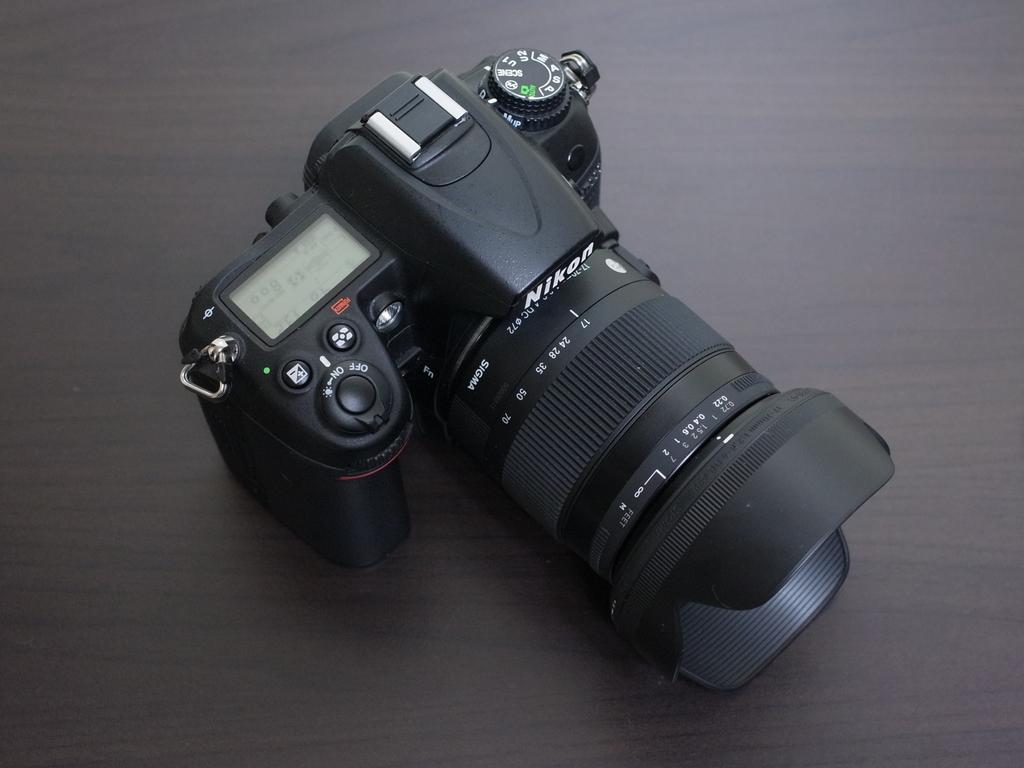What brand of camera is this?
Ensure brevity in your answer.  Nikon. Is the on/off button currently in the "on" position?
Your response must be concise. Yes. 